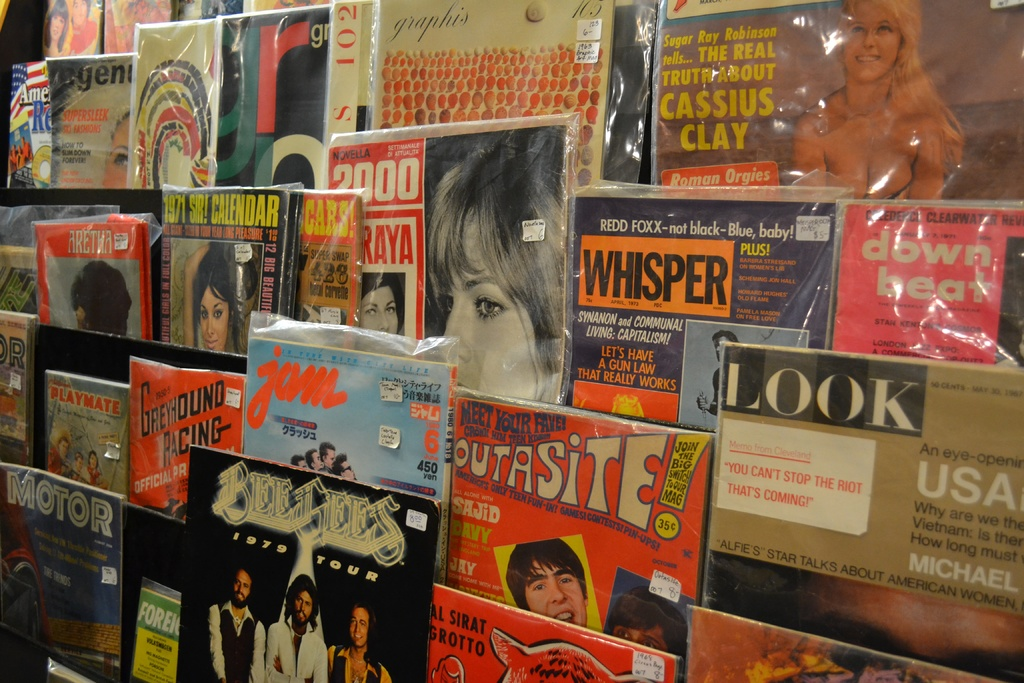Provide a one-sentence caption for the provided image. The image showcases a diverse collection of vintage magazines covering an array of topics, from celebrity gossip and sports to cultural insights, reflecting the pop culture trends and societal interests of their times. 